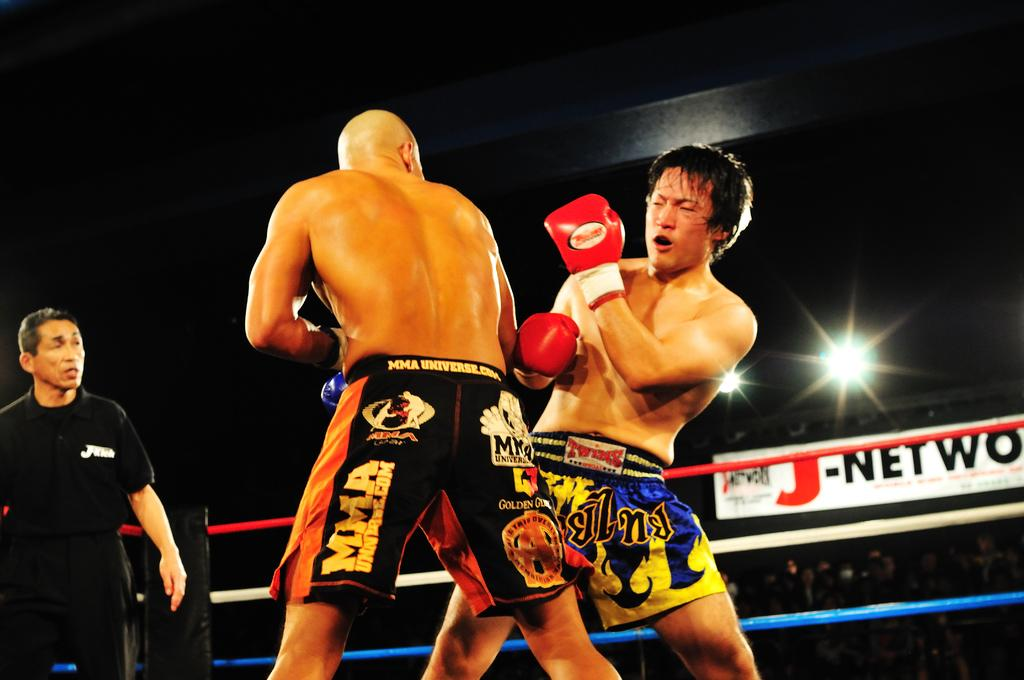<image>
Render a clear and concise summary of the photo. Two boxers fight in the ring as the crowd look on under a large advert for J - Networks 